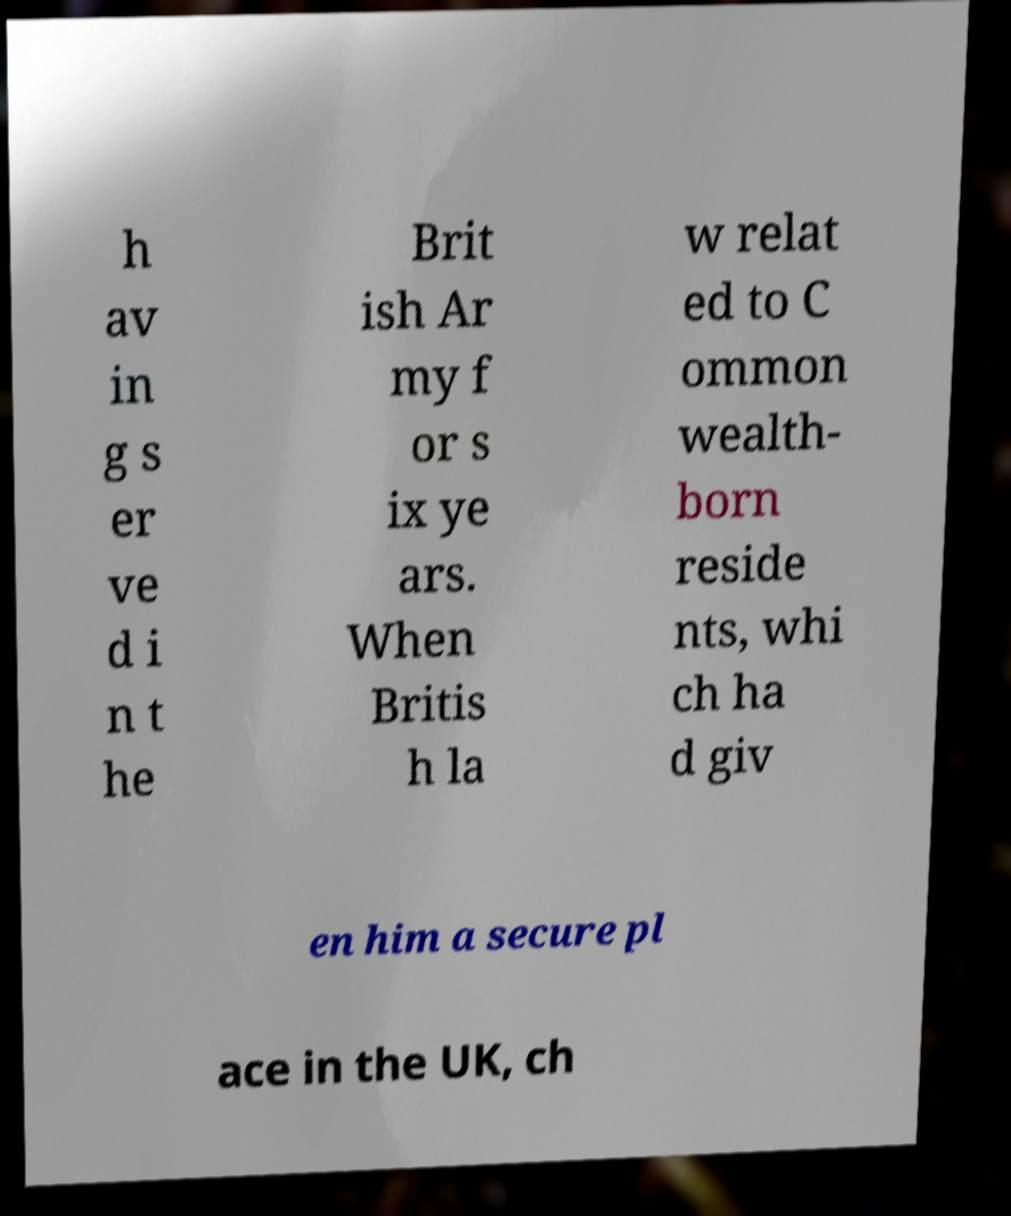Could you assist in decoding the text presented in this image and type it out clearly? h av in g s er ve d i n t he Brit ish Ar my f or s ix ye ars. When Britis h la w relat ed to C ommon wealth- born reside nts, whi ch ha d giv en him a secure pl ace in the UK, ch 